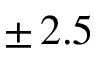Convert formula to latex. <formula><loc_0><loc_0><loc_500><loc_500>\pm \, 2 . 5</formula> 